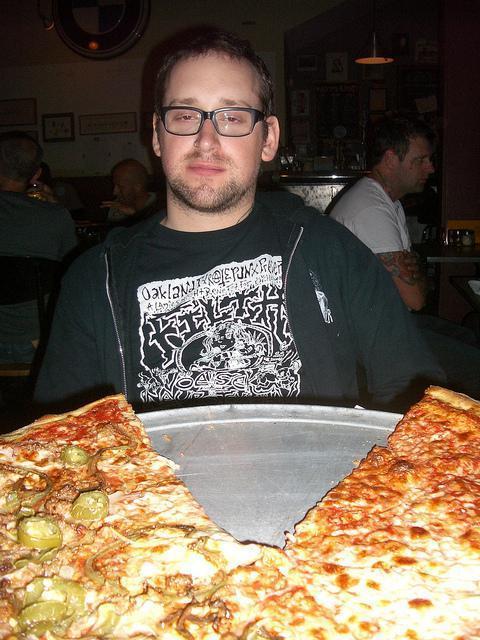How many pieces are missing?
Give a very brief answer. 1. How many people are there?
Give a very brief answer. 4. 